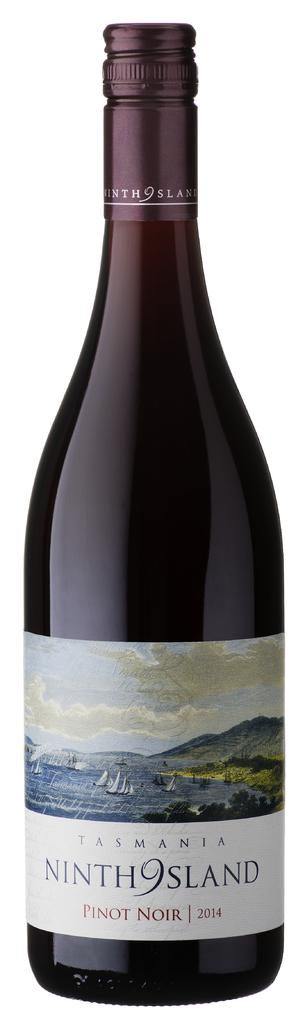<image>
Give a short and clear explanation of the subsequent image. bottle of wine the brand is nith 9 island 